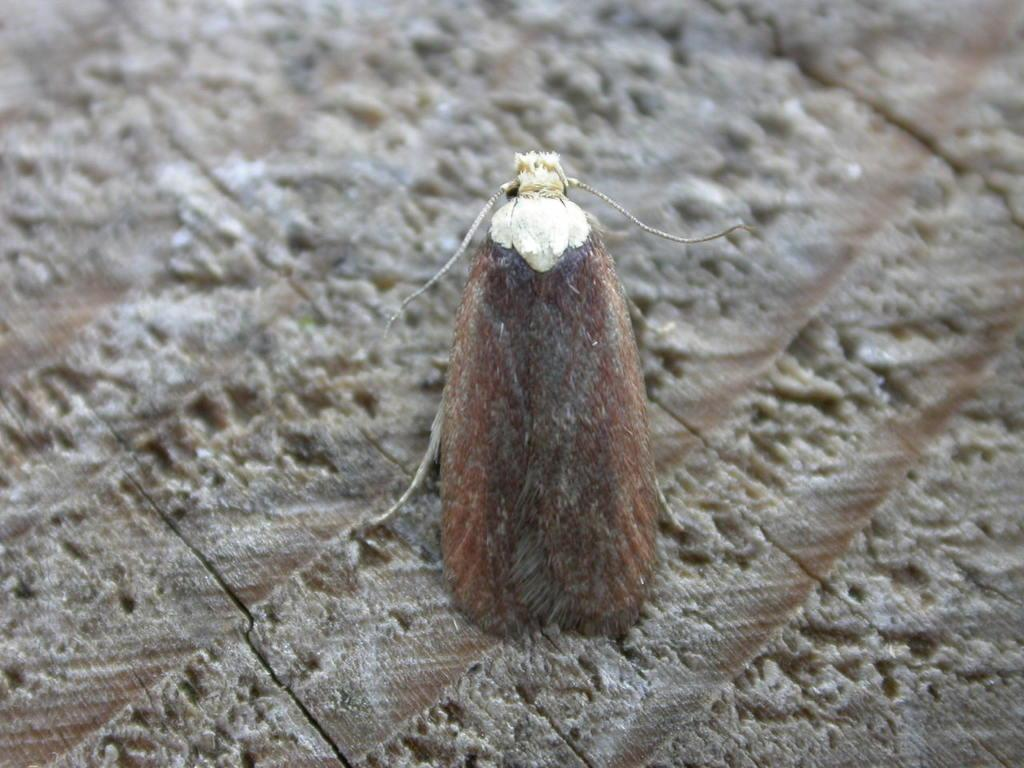What type of creature can be seen in the image? There is an insect in the image. Where is the insect located? The insect is on a wooden surface. What type of jelly is the crow eating in the image? There is no crow or jelly present in the image; it only features an insect on a wooden surface. 